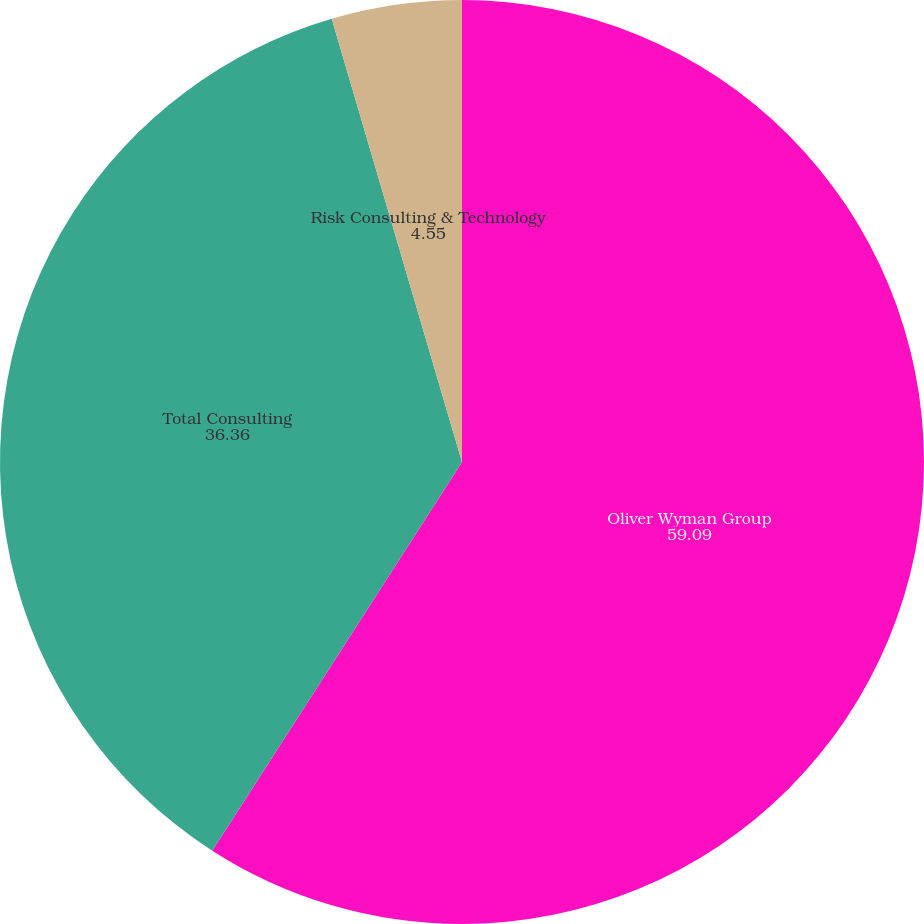<chart> <loc_0><loc_0><loc_500><loc_500><pie_chart><fcel>Oliver Wyman Group<fcel>Total Consulting<fcel>Risk Consulting & Technology<nl><fcel>59.09%<fcel>36.36%<fcel>4.55%<nl></chart> 